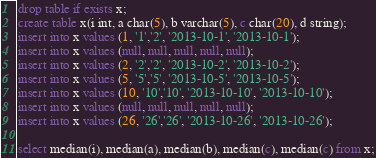Convert code to text. <code><loc_0><loc_0><loc_500><loc_500><_SQL_>drop table if exists x;
create table x(i int, a char(5), b varchar(5), c char(20), d string);
insert into x values (1, '1','2', '2013-10-1', '2013-10-1');
insert into x values (null, null, null, null, null);
insert into x values (2, '2','2', '2013-10-2', '2013-10-2');
insert into x values (5, '5','5', '2013-10-5', '2013-10-5');
insert into x values (10, '10','10', '2013-10-10', '2013-10-10');
insert into x values (null, null, null, null, null);
insert into x values (26, '26','26', '2013-10-26', '2013-10-26');

select median(i), median(a), median(b), median(c), median(c) from x;
</code> 